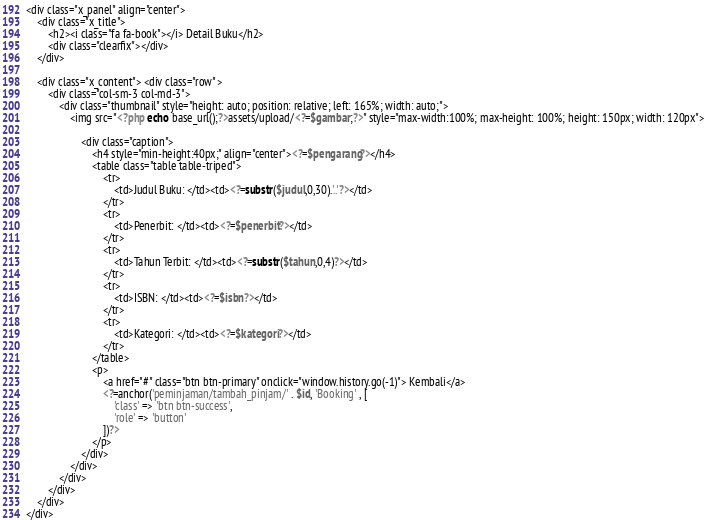<code> <loc_0><loc_0><loc_500><loc_500><_PHP_><div class="x_panel" align="center"> 
	<div class="x_title"> 
		<h2><i class="fa fa-book"></i> Detail Buku</h2> 
		<div class="clearfix"></div> 
	</div> 
	
	<div class="x_content"> <div class="row" > 
		<div class="col-sm-3 col-md-3"> 
			<div class="thumbnail" style="height: auto; position: relative; left: 165%; width: auto;"> 
				<img src="<?php echo base_url();?>assets/upload/<?=$gambar;?>" style="max-width:100%; max-height: 100%; height: 150px; width: 120px"> 
					
					<div class="caption"> 
						<h4 style="min-height:40px;" align="center"><?=$pengarang?></h4> 
						<table class="table table-triped"> 
							<tr> 
								<td>Judul Buku: </td><td><?=substr($judul,0,30).'..'?></td> 
							</tr> 
							<tr> 
								<td>Penerbit: </td><td><?=$penerbit?></td> 
							</tr> 
							<tr> 
								<td>Tahun Terbit: </td><td><?=substr($tahun,0,4)?></td> 
							</tr> 
							<tr> 
								<td>ISBN: </td><td><?=$isbn?></td> 
							</tr> 
							<tr> 
								<td>Kategori: </td><td><?=$kategori?></td> 
							</tr> 
						</table> 
						<p> 
							<a href="#" class="btn btn-primary" onclick="window.history.go(-1)"> Kembali</a> 
							<?=anchor('peminjaman/tambah_pinjam/' . $id, 'Booking' , [ 
								'class' => 'btn btn-success', 
								'role' => 'button' 
							])?> 
						</p> 
					</div> 
				</div>
			</div>
		</div>
	</div>
</div></code> 